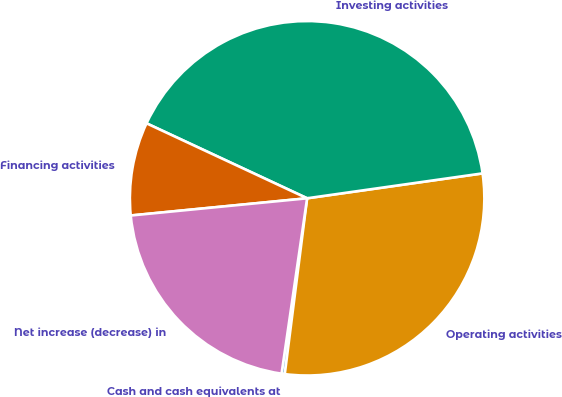Convert chart to OTSL. <chart><loc_0><loc_0><loc_500><loc_500><pie_chart><fcel>Cash and cash equivalents at<fcel>Operating activities<fcel>Investing activities<fcel>Financing activities<fcel>Net increase (decrease) in<nl><fcel>0.29%<fcel>29.26%<fcel>40.81%<fcel>8.5%<fcel>21.15%<nl></chart> 